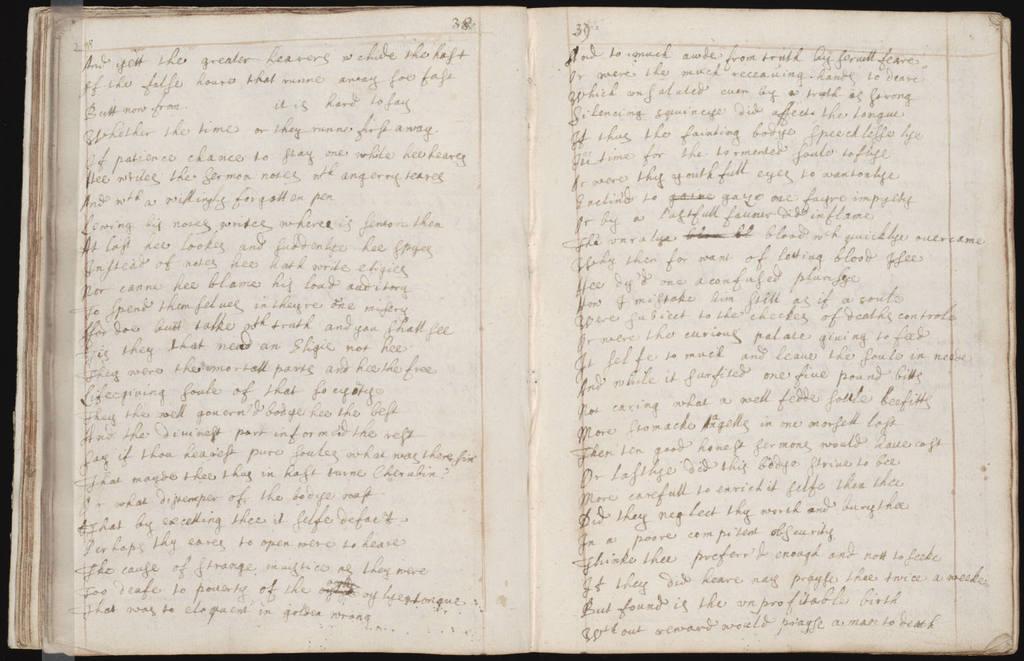What is the page number of the left page?
Provide a short and direct response. 38. 